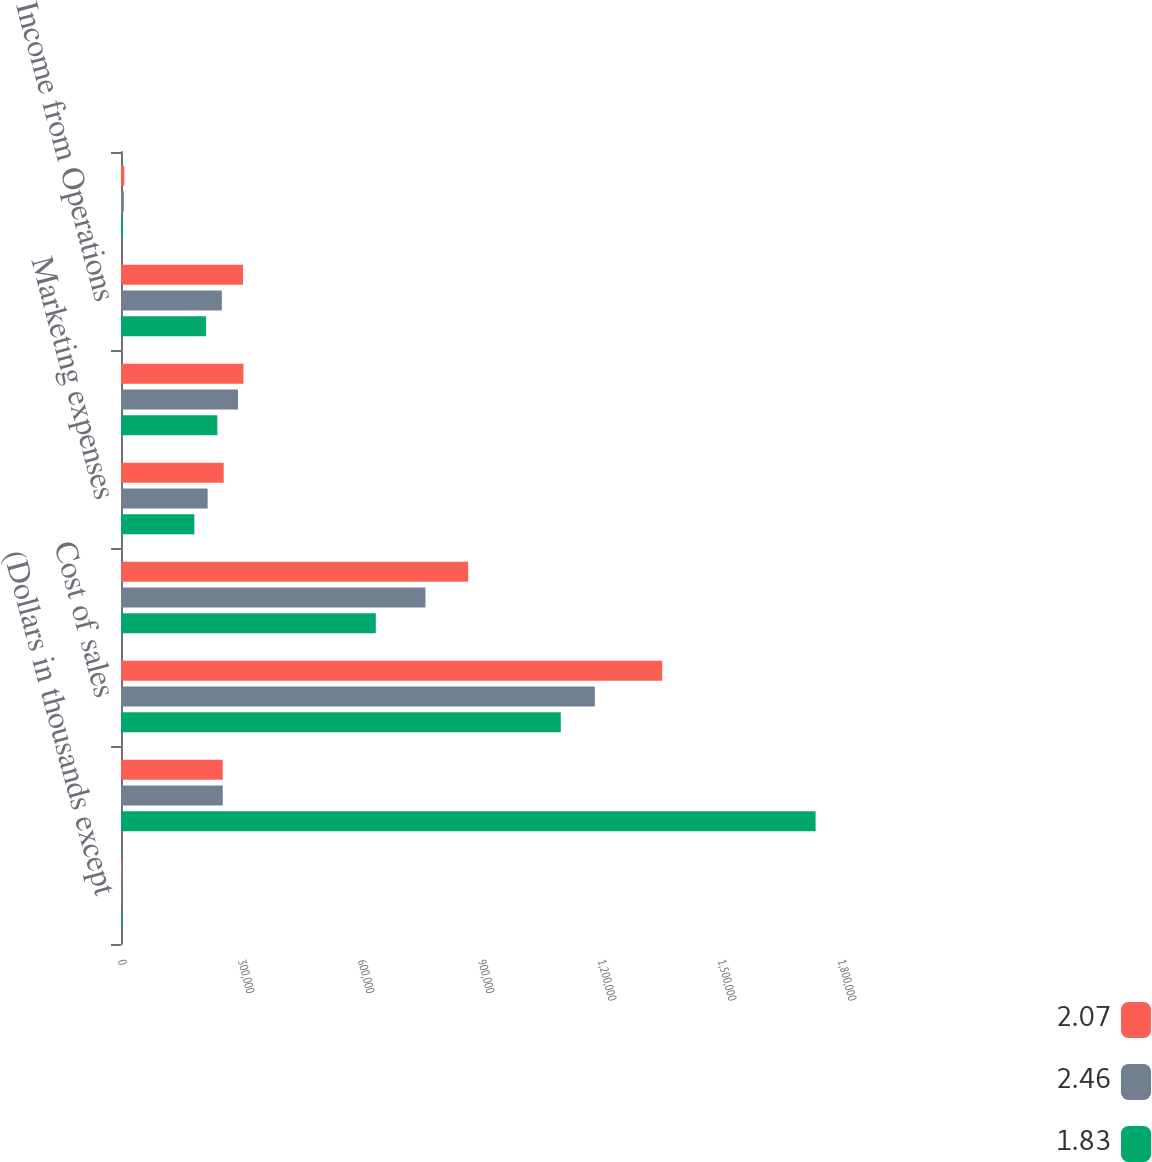Convert chart to OTSL. <chart><loc_0><loc_0><loc_500><loc_500><stacked_bar_chart><ecel><fcel>(Dollars in thousands except<fcel>Net Sales<fcel>Cost of sales<fcel>Gross Profit<fcel>Marketing expenses<fcel>Selling general and<fcel>Income from Operations<fcel>Equity in earnings of<nl><fcel>2.07<fcel>2007<fcel>254422<fcel>1.35304e+06<fcel>867898<fcel>256743<fcel>306121<fcel>305034<fcel>8236<nl><fcel>2.46<fcel>2006<fcel>254422<fcel>1.18452e+06<fcel>761137<fcel>216661<fcel>292374<fcel>252102<fcel>7135<nl><fcel>1.83<fcel>2005<fcel>1.73651e+06<fcel>1.09951e+06<fcel>637000<fcel>183422<fcel>240802<fcel>212776<fcel>4790<nl></chart> 